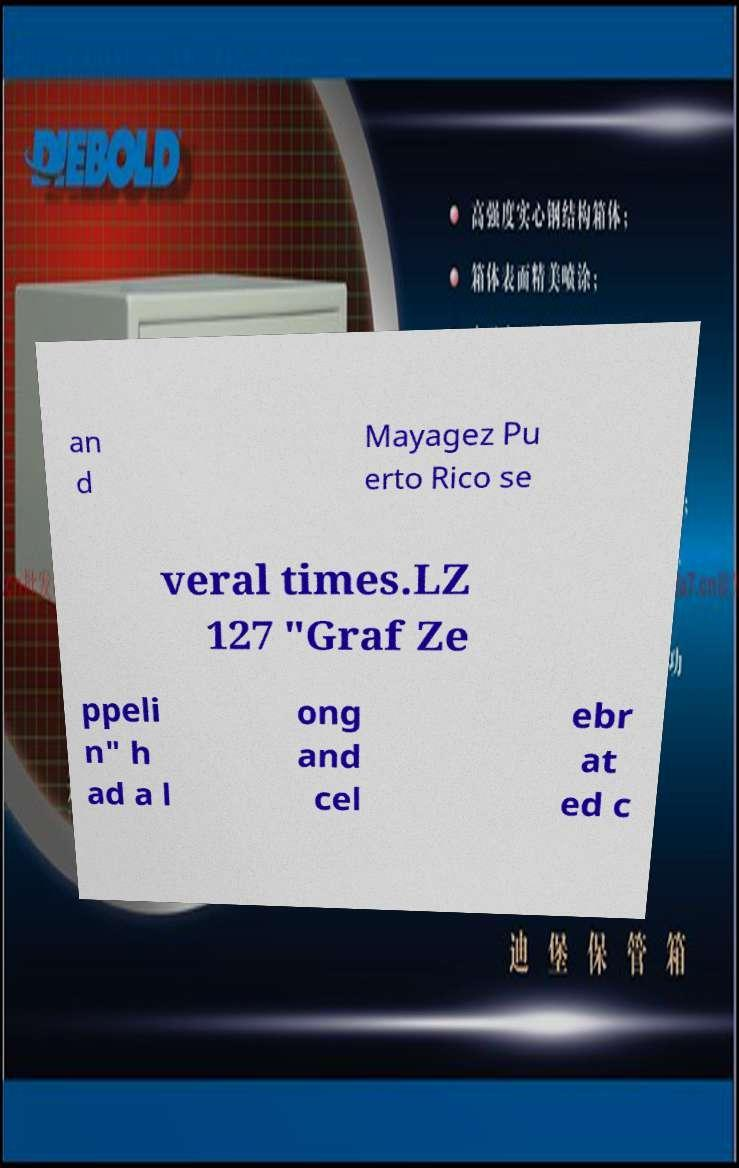Can you read and provide the text displayed in the image?This photo seems to have some interesting text. Can you extract and type it out for me? an d Mayagez Pu erto Rico se veral times.LZ 127 "Graf Ze ppeli n" h ad a l ong and cel ebr at ed c 